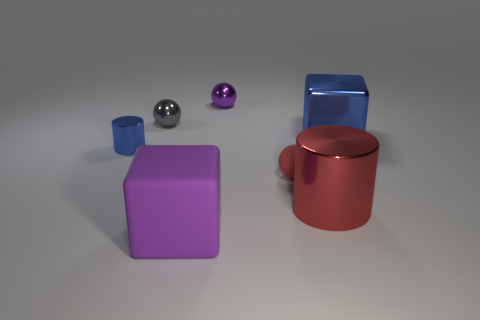Add 1 red spheres. How many objects exist? 8 Subtract all cylinders. How many objects are left? 5 Subtract 0 red cubes. How many objects are left? 7 Subtract all tiny gray balls. Subtract all spheres. How many objects are left? 3 Add 7 gray objects. How many gray objects are left? 8 Add 7 tiny red matte objects. How many tiny red matte objects exist? 8 